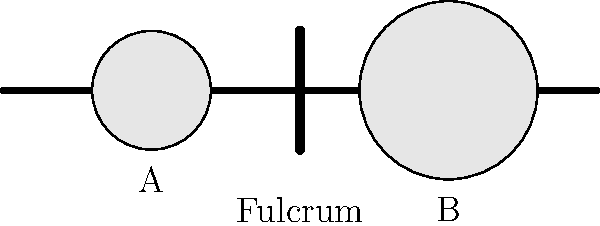Look at the picture of the lever. If weight A is 5 pounds and weight B is 10 pounds, which side of the lever will go down? Let's think about this step-by-step:

1. A lever is a simple machine that helps lift heavy objects.
2. The fulcrum is the point in the middle where the lever balances.
3. Weight A is closer to the fulcrum than weight B.
4. Weight A is 5 pounds, which is lighter than weight B (10 pounds).
5. When an object is farther from the fulcrum, it has more force.
6. Even though weight B is heavier, it's also farther from the fulcrum.
7. This extra distance gives weight B more force to push down the lever.

So, the side with weight B will go down because it has more force due to its distance from the fulcrum, even though it's heavier.
Answer: Side B 